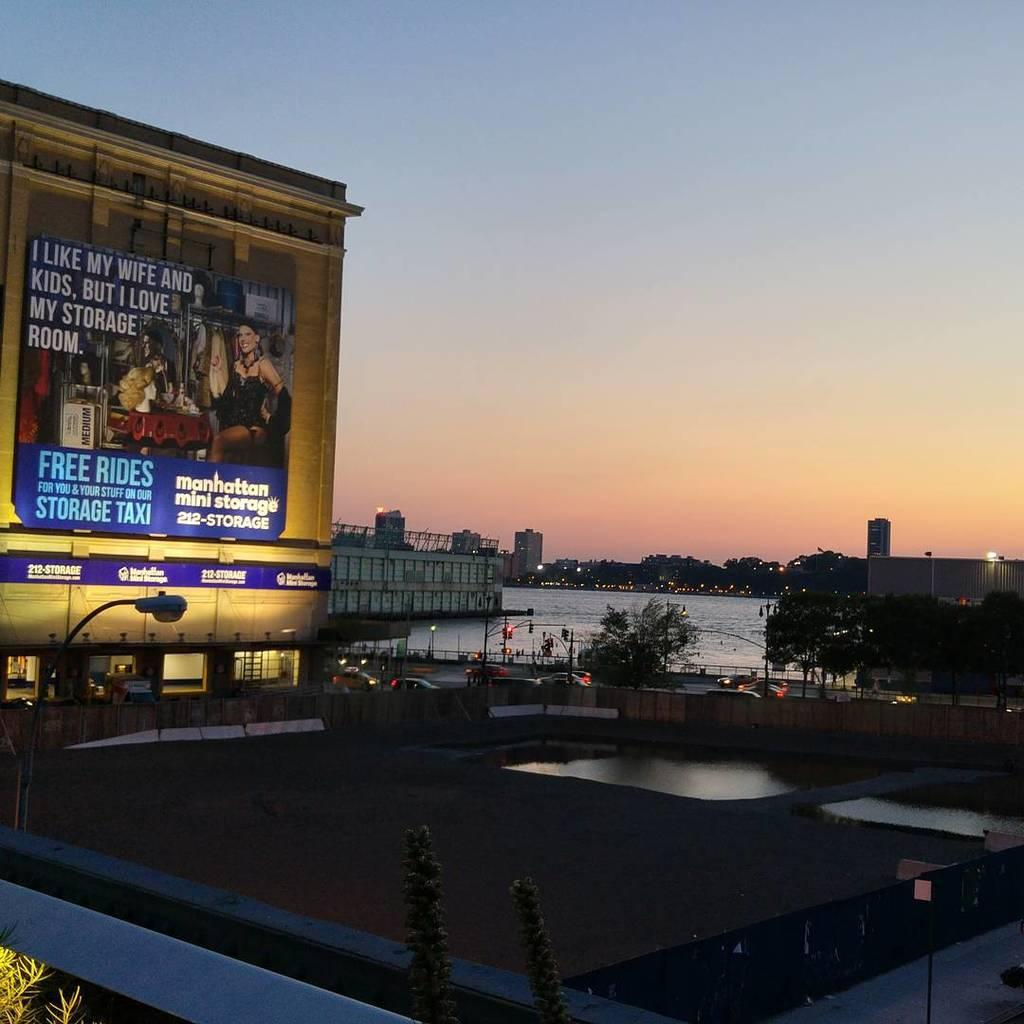<image>
Relay a brief, clear account of the picture shown. a billboard says I like My Wife But I love my Storage Room 